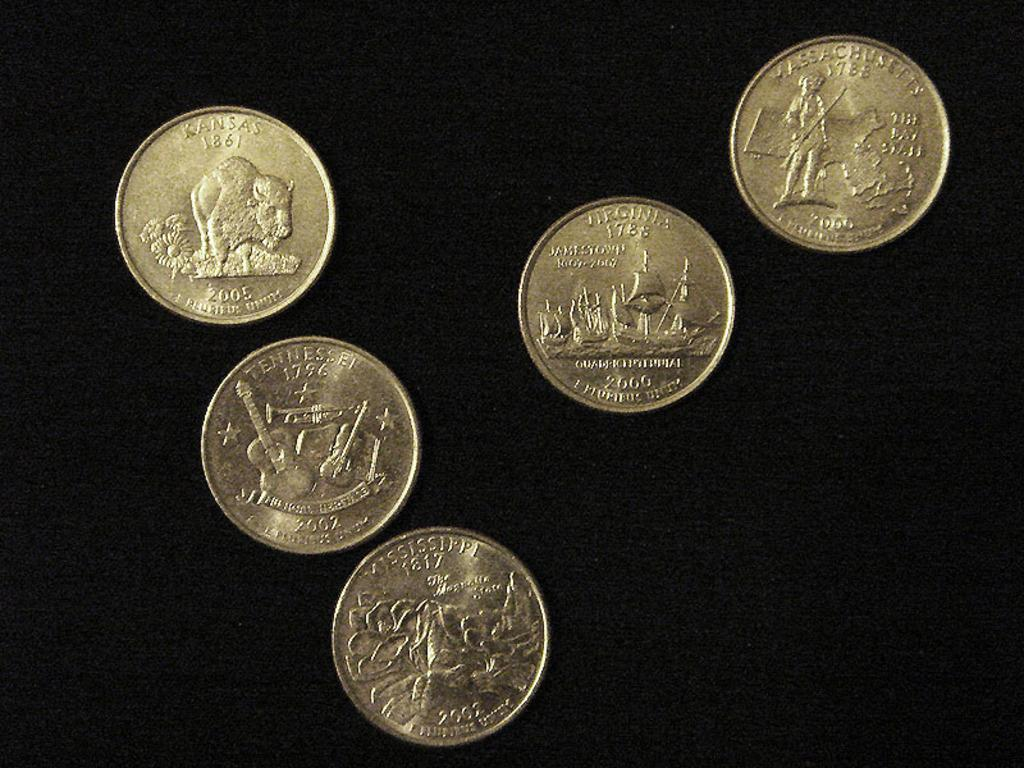<image>
Present a compact description of the photo's key features. Various US quarters from states like Virginia and Kansas 